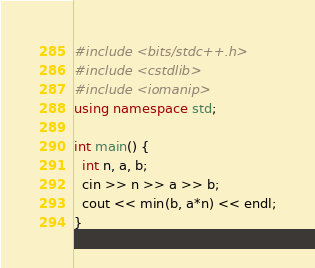Convert code to text. <code><loc_0><loc_0><loc_500><loc_500><_C++_>#include <bits/stdc++.h>
#include <cstdlib>
#include <iomanip>
using namespace std;

int main() {
  int n, a, b;
  cin >> n >> a >> b;
  cout << min(b, a*n) << endl;
}</code> 